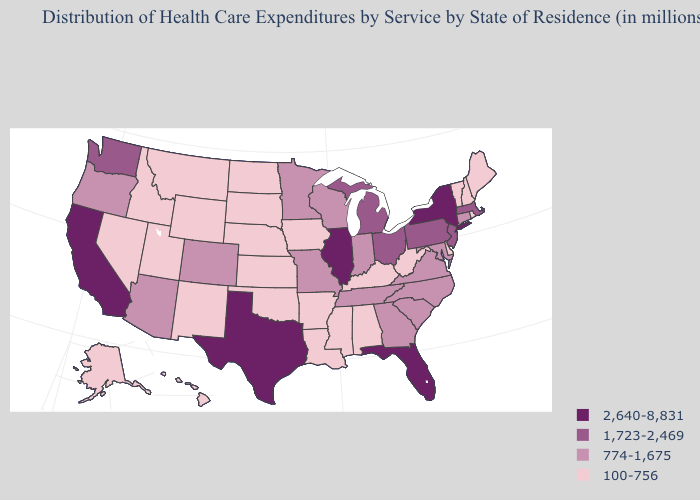Among the states that border Rhode Island , which have the lowest value?
Short answer required. Connecticut. What is the value of Mississippi?
Quick response, please. 100-756. Does Minnesota have a lower value than Michigan?
Concise answer only. Yes. What is the highest value in the USA?
Answer briefly. 2,640-8,831. What is the value of Pennsylvania?
Answer briefly. 1,723-2,469. What is the value of New York?
Short answer required. 2,640-8,831. What is the value of Kansas?
Give a very brief answer. 100-756. Name the states that have a value in the range 100-756?
Keep it brief. Alabama, Alaska, Arkansas, Delaware, Hawaii, Idaho, Iowa, Kansas, Kentucky, Louisiana, Maine, Mississippi, Montana, Nebraska, Nevada, New Hampshire, New Mexico, North Dakota, Oklahoma, Rhode Island, South Dakota, Utah, Vermont, West Virginia, Wyoming. Does Wyoming have the lowest value in the USA?
Write a very short answer. Yes. How many symbols are there in the legend?
Concise answer only. 4. Among the states that border Montana , which have the lowest value?
Short answer required. Idaho, North Dakota, South Dakota, Wyoming. Name the states that have a value in the range 774-1,675?
Answer briefly. Arizona, Colorado, Connecticut, Georgia, Indiana, Maryland, Minnesota, Missouri, North Carolina, Oregon, South Carolina, Tennessee, Virginia, Wisconsin. What is the lowest value in the USA?
Be succinct. 100-756. Name the states that have a value in the range 2,640-8,831?
Keep it brief. California, Florida, Illinois, New York, Texas. What is the value of North Carolina?
Concise answer only. 774-1,675. 